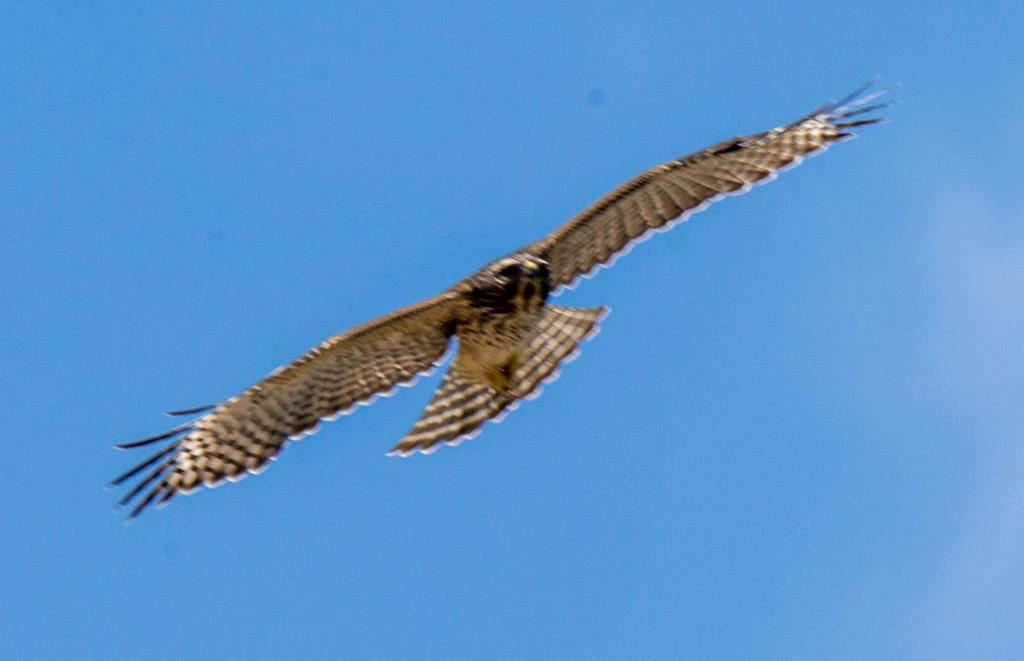What type of animal is in the image? There is a bird in the image. What colors can be seen on the bird? The bird has a black and white color combination. What is the bird doing in the image? The bird is flying in the air. What is the color of the sky in the background of the image? There is a blue sky in the background of the image. What is the bird's opinion on the current political climate? Birds do not have opinions, as they are animals and not capable of forming opinions on political matters. 